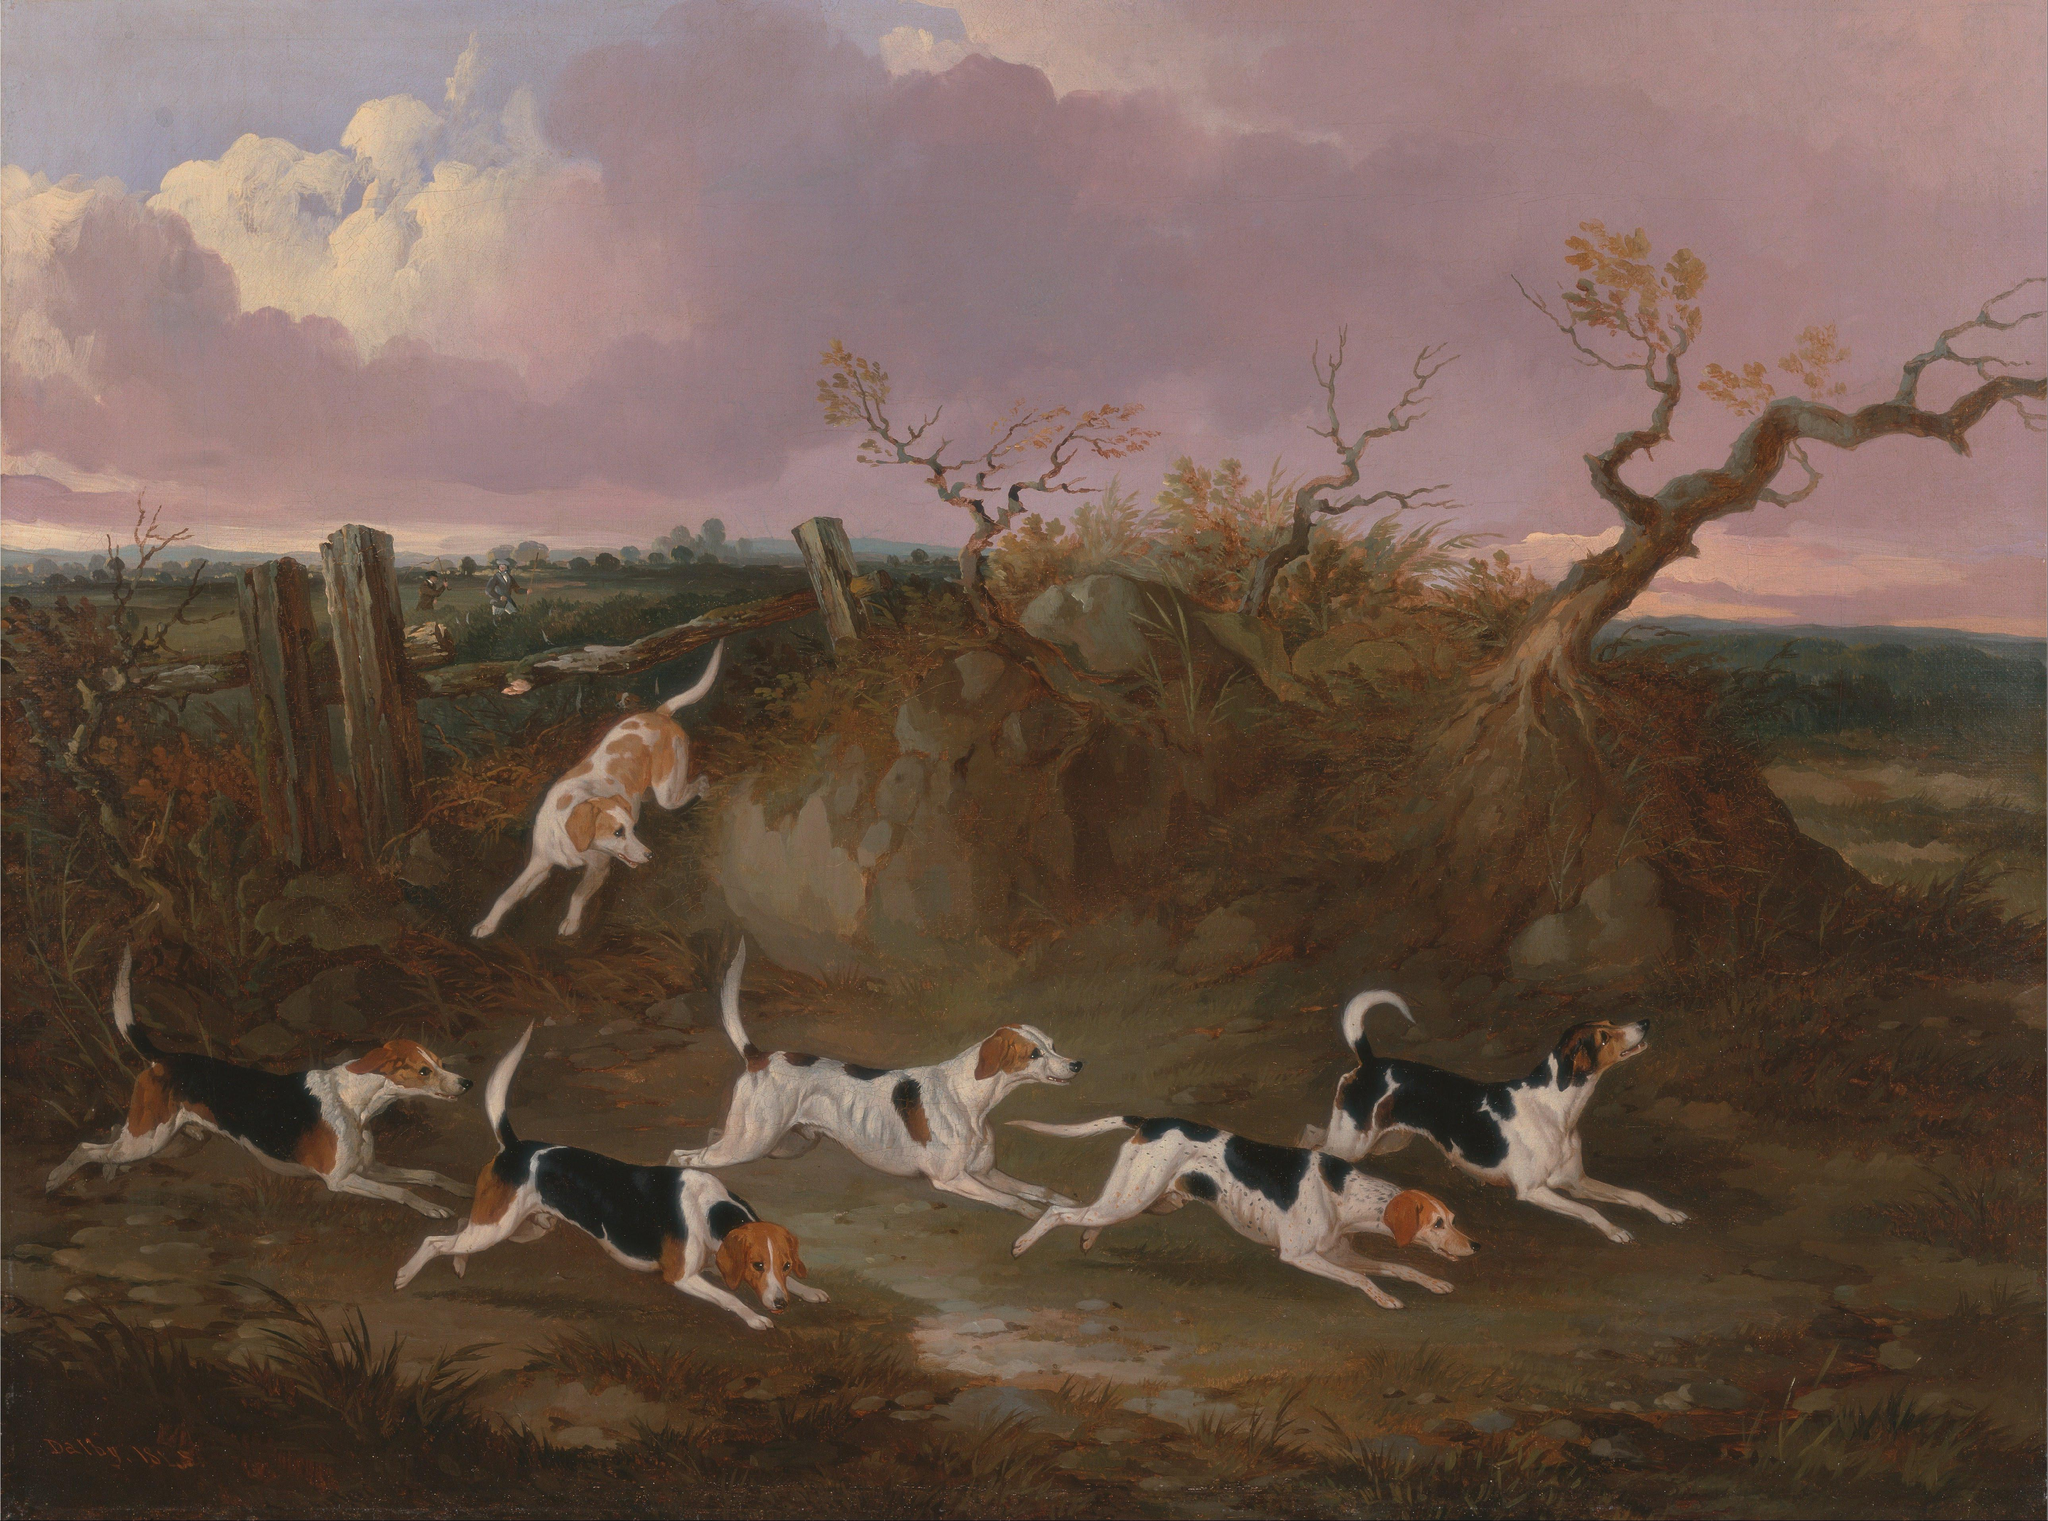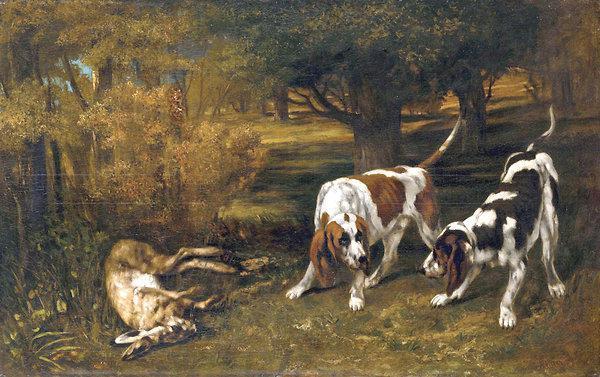The first image is the image on the left, the second image is the image on the right. For the images displayed, is the sentence "There are no more than three animals in the image on the right" factually correct? Answer yes or no. Yes. 